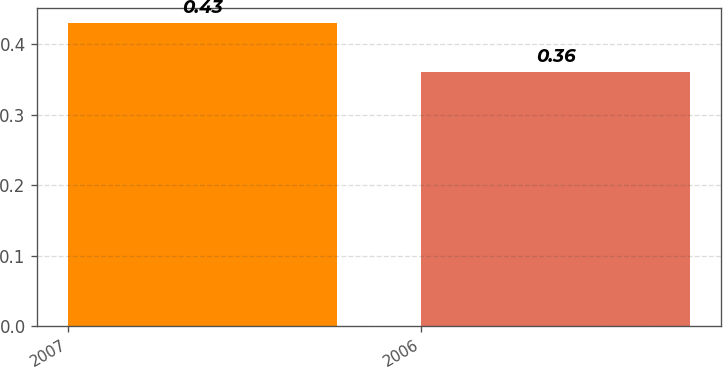Convert chart to OTSL. <chart><loc_0><loc_0><loc_500><loc_500><bar_chart><fcel>2007<fcel>2006<nl><fcel>0.43<fcel>0.36<nl></chart> 